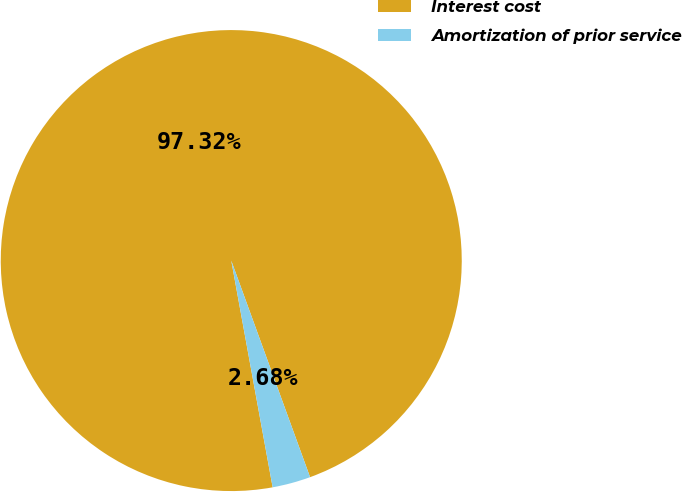Convert chart to OTSL. <chart><loc_0><loc_0><loc_500><loc_500><pie_chart><fcel>Interest cost<fcel>Amortization of prior service<nl><fcel>97.32%<fcel>2.68%<nl></chart> 